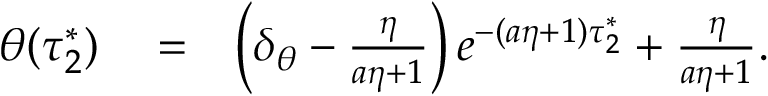Convert formula to latex. <formula><loc_0><loc_0><loc_500><loc_500>\begin{array} { r l r } { \theta ( \tau _ { 2 } ^ { * } ) } & = } & { \left ( \delta _ { \theta } - \frac { \eta } { a \eta + 1 } \right ) e ^ { - ( a \eta + 1 ) \tau _ { 2 } ^ { * } } + \frac { \eta } { a \eta + 1 } . } \end{array}</formula> 